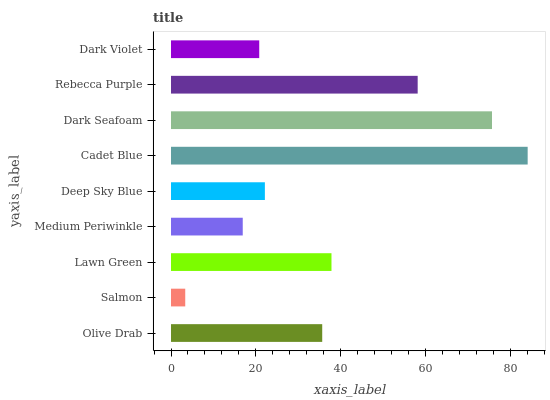Is Salmon the minimum?
Answer yes or no. Yes. Is Cadet Blue the maximum?
Answer yes or no. Yes. Is Lawn Green the minimum?
Answer yes or no. No. Is Lawn Green the maximum?
Answer yes or no. No. Is Lawn Green greater than Salmon?
Answer yes or no. Yes. Is Salmon less than Lawn Green?
Answer yes or no. Yes. Is Salmon greater than Lawn Green?
Answer yes or no. No. Is Lawn Green less than Salmon?
Answer yes or no. No. Is Olive Drab the high median?
Answer yes or no. Yes. Is Olive Drab the low median?
Answer yes or no. Yes. Is Dark Seafoam the high median?
Answer yes or no. No. Is Deep Sky Blue the low median?
Answer yes or no. No. 